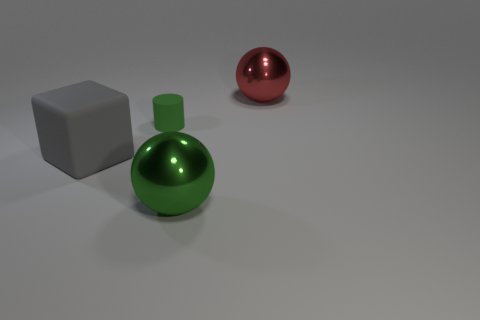Add 4 tiny blue blocks. How many objects exist? 8 Subtract 0 red cylinders. How many objects are left? 4 Subtract all cylinders. How many objects are left? 3 Subtract 2 spheres. How many spheres are left? 0 Subtract all gray spheres. Subtract all purple cylinders. How many spheres are left? 2 Subtract all cyan cylinders. How many green balls are left? 1 Subtract all green metal things. Subtract all big spheres. How many objects are left? 1 Add 2 big green shiny objects. How many big green shiny objects are left? 3 Add 4 big shiny things. How many big shiny things exist? 6 